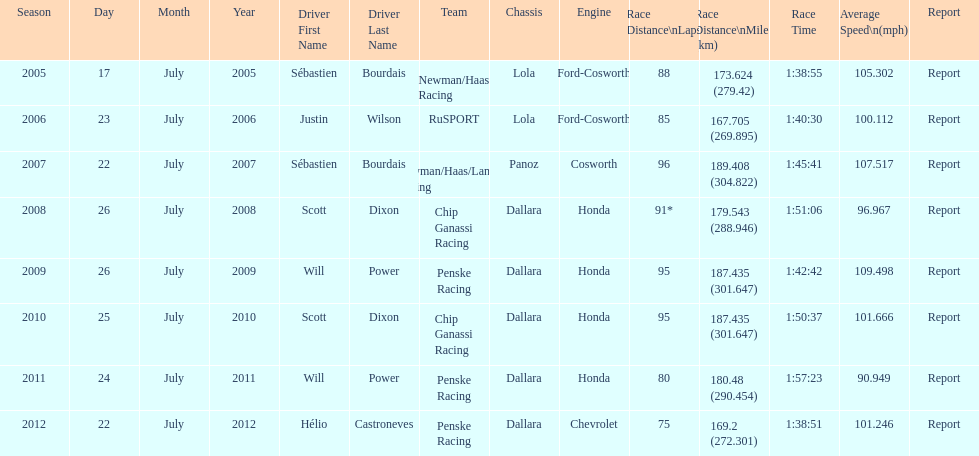Help me parse the entirety of this table. {'header': ['Season', 'Day', 'Month', 'Year', 'Driver First Name', 'Driver Last Name', 'Team', 'Chassis', 'Engine', 'Race Distance\\nLaps', 'Race Distance\\nMiles (km)', 'Race Time', 'Average Speed\\n(mph)', 'Report'], 'rows': [['2005', '17', 'July', '2005', 'Sébastien', 'Bourdais', 'Newman/Haas Racing', 'Lola', 'Ford-Cosworth', '88', '173.624 (279.42)', '1:38:55', '105.302', 'Report'], ['2006', '23', 'July', '2006', 'Justin', 'Wilson', 'RuSPORT', 'Lola', 'Ford-Cosworth', '85', '167.705 (269.895)', '1:40:30', '100.112', 'Report'], ['2007', '22', 'July', '2007', 'Sébastien', 'Bourdais', 'Newman/Haas/Lanigan Racing', 'Panoz', 'Cosworth', '96', '189.408 (304.822)', '1:45:41', '107.517', 'Report'], ['2008', '26', 'July', '2008', 'Scott', 'Dixon', 'Chip Ganassi Racing', 'Dallara', 'Honda', '91*', '179.543 (288.946)', '1:51:06', '96.967', 'Report'], ['2009', '26', 'July', '2009', 'Will', 'Power', 'Penske Racing', 'Dallara', 'Honda', '95', '187.435 (301.647)', '1:42:42', '109.498', 'Report'], ['2010', '25', 'July', '2010', 'Scott', 'Dixon', 'Chip Ganassi Racing', 'Dallara', 'Honda', '95', '187.435 (301.647)', '1:50:37', '101.666', 'Report'], ['2011', '24', 'July', '2011', 'Will', 'Power', 'Penske Racing', 'Dallara', 'Honda', '80', '180.48 (290.454)', '1:57:23', '90.949', 'Report'], ['2012', '22', 'July', '2012', 'Hélio', 'Castroneves', 'Penske Racing', 'Dallara', 'Chevrolet', '75', '169.2 (272.301)', '1:38:51', '101.246', 'Report']]} How many flags other than france (the first flag) are represented? 3. 